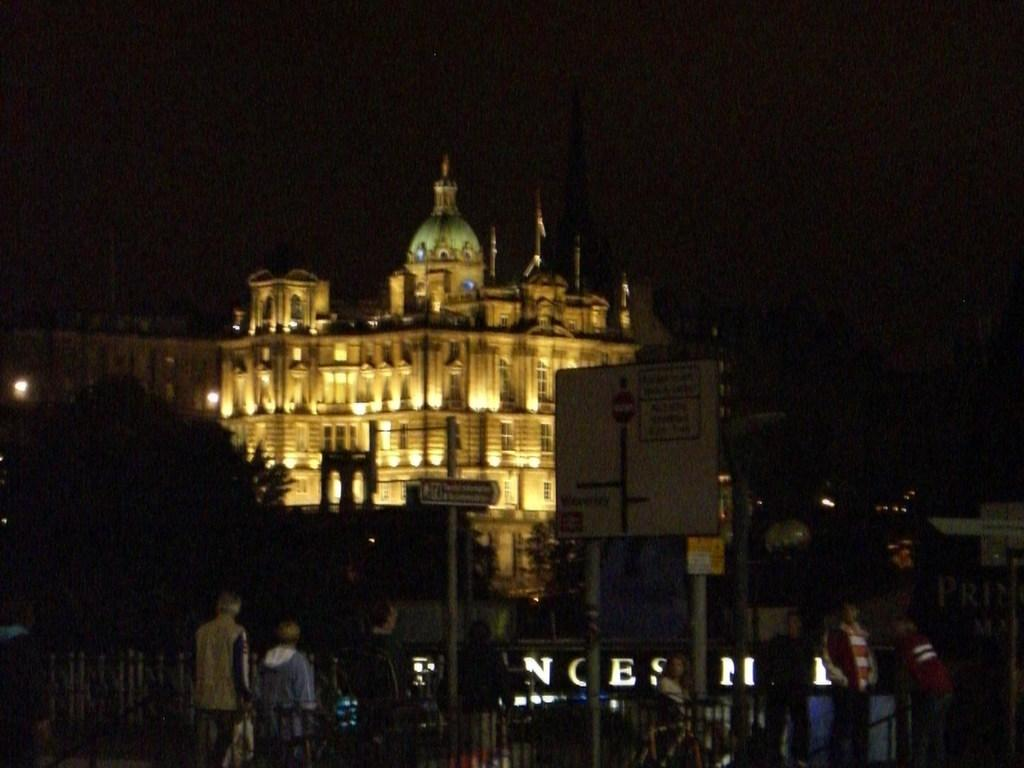What are the people in the image doing? The people in the image are standing beside a fence. What is the name board on the pole used for? The name board on the pole is used to display a name or sign. What type of vegetation can be seen in the image? There are trees visible in the image. What can be seen in the background of the image? There is a building with lights in the background of the image. Can you tell me the credit score of the person standing beside the fence in the image? There is no information about credit scores in the image, as it only shows people standing beside a fence, a name board on a pole, trees, and a building with lights in the background. Is there a zephyr blowing in the image? There is no mention of a zephyr or any wind in the image, so it cannot be determined from the image alone. 